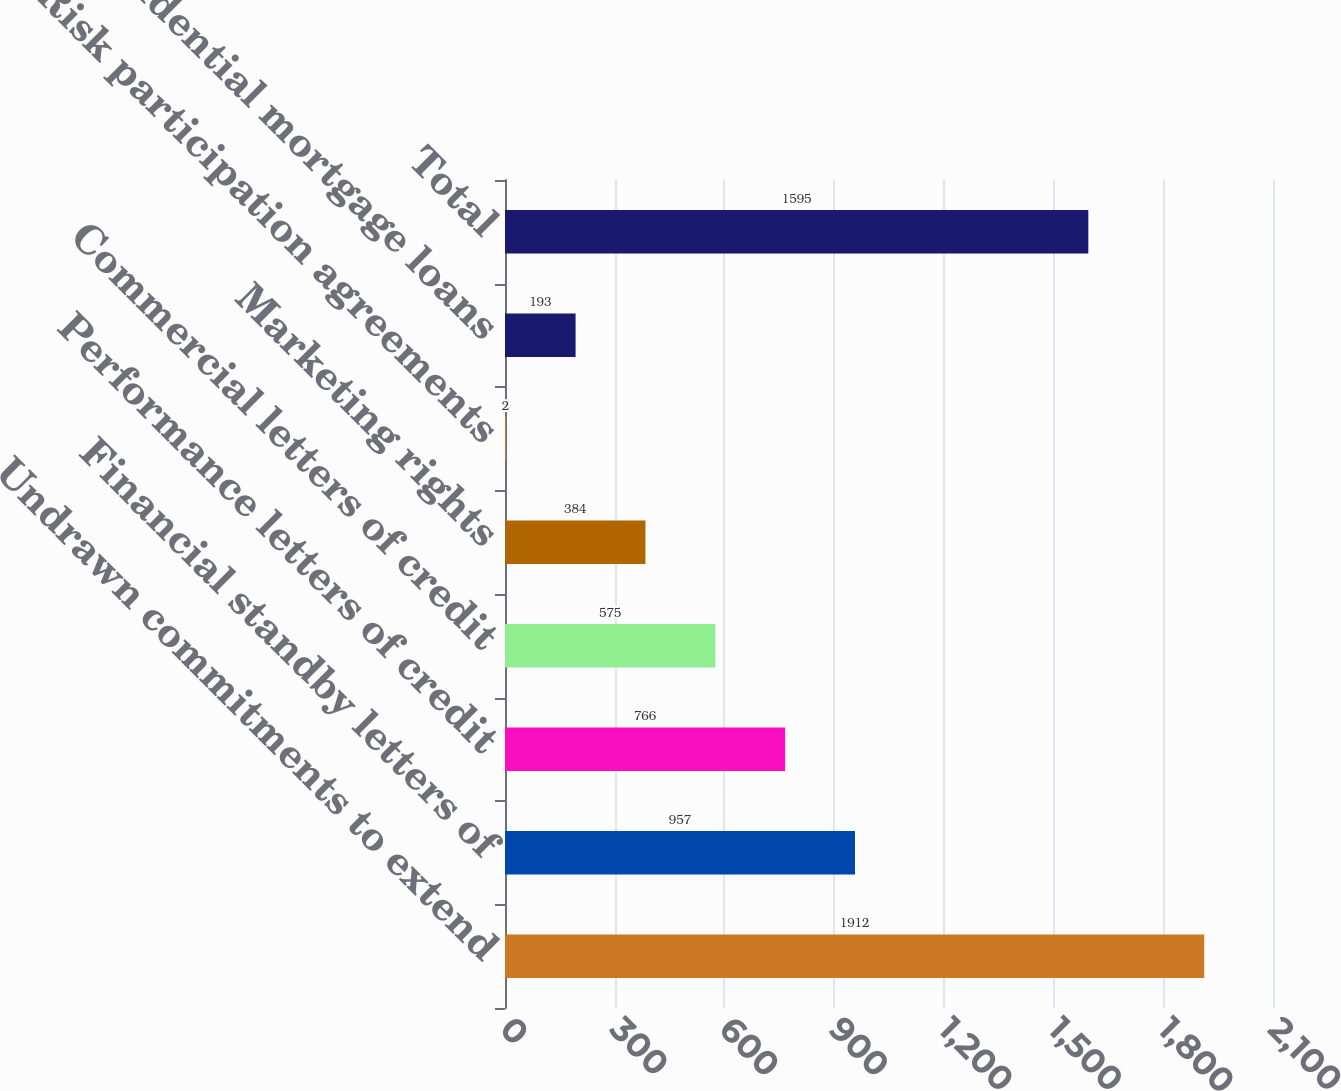<chart> <loc_0><loc_0><loc_500><loc_500><bar_chart><fcel>Undrawn commitments to extend<fcel>Financial standby letters of<fcel>Performance letters of credit<fcel>Commercial letters of credit<fcel>Marketing rights<fcel>Risk participation agreements<fcel>Residential mortgage loans<fcel>Total<nl><fcel>1912<fcel>957<fcel>766<fcel>575<fcel>384<fcel>2<fcel>193<fcel>1595<nl></chart> 